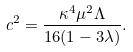<formula> <loc_0><loc_0><loc_500><loc_500>c ^ { 2 } = \frac { \kappa ^ { 4 } \mu ^ { 2 } \Lambda } { 1 6 ( 1 - 3 \lambda ) } .</formula> 